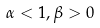<formula> <loc_0><loc_0><loc_500><loc_500>\alpha < 1 , \beta > 0</formula> 